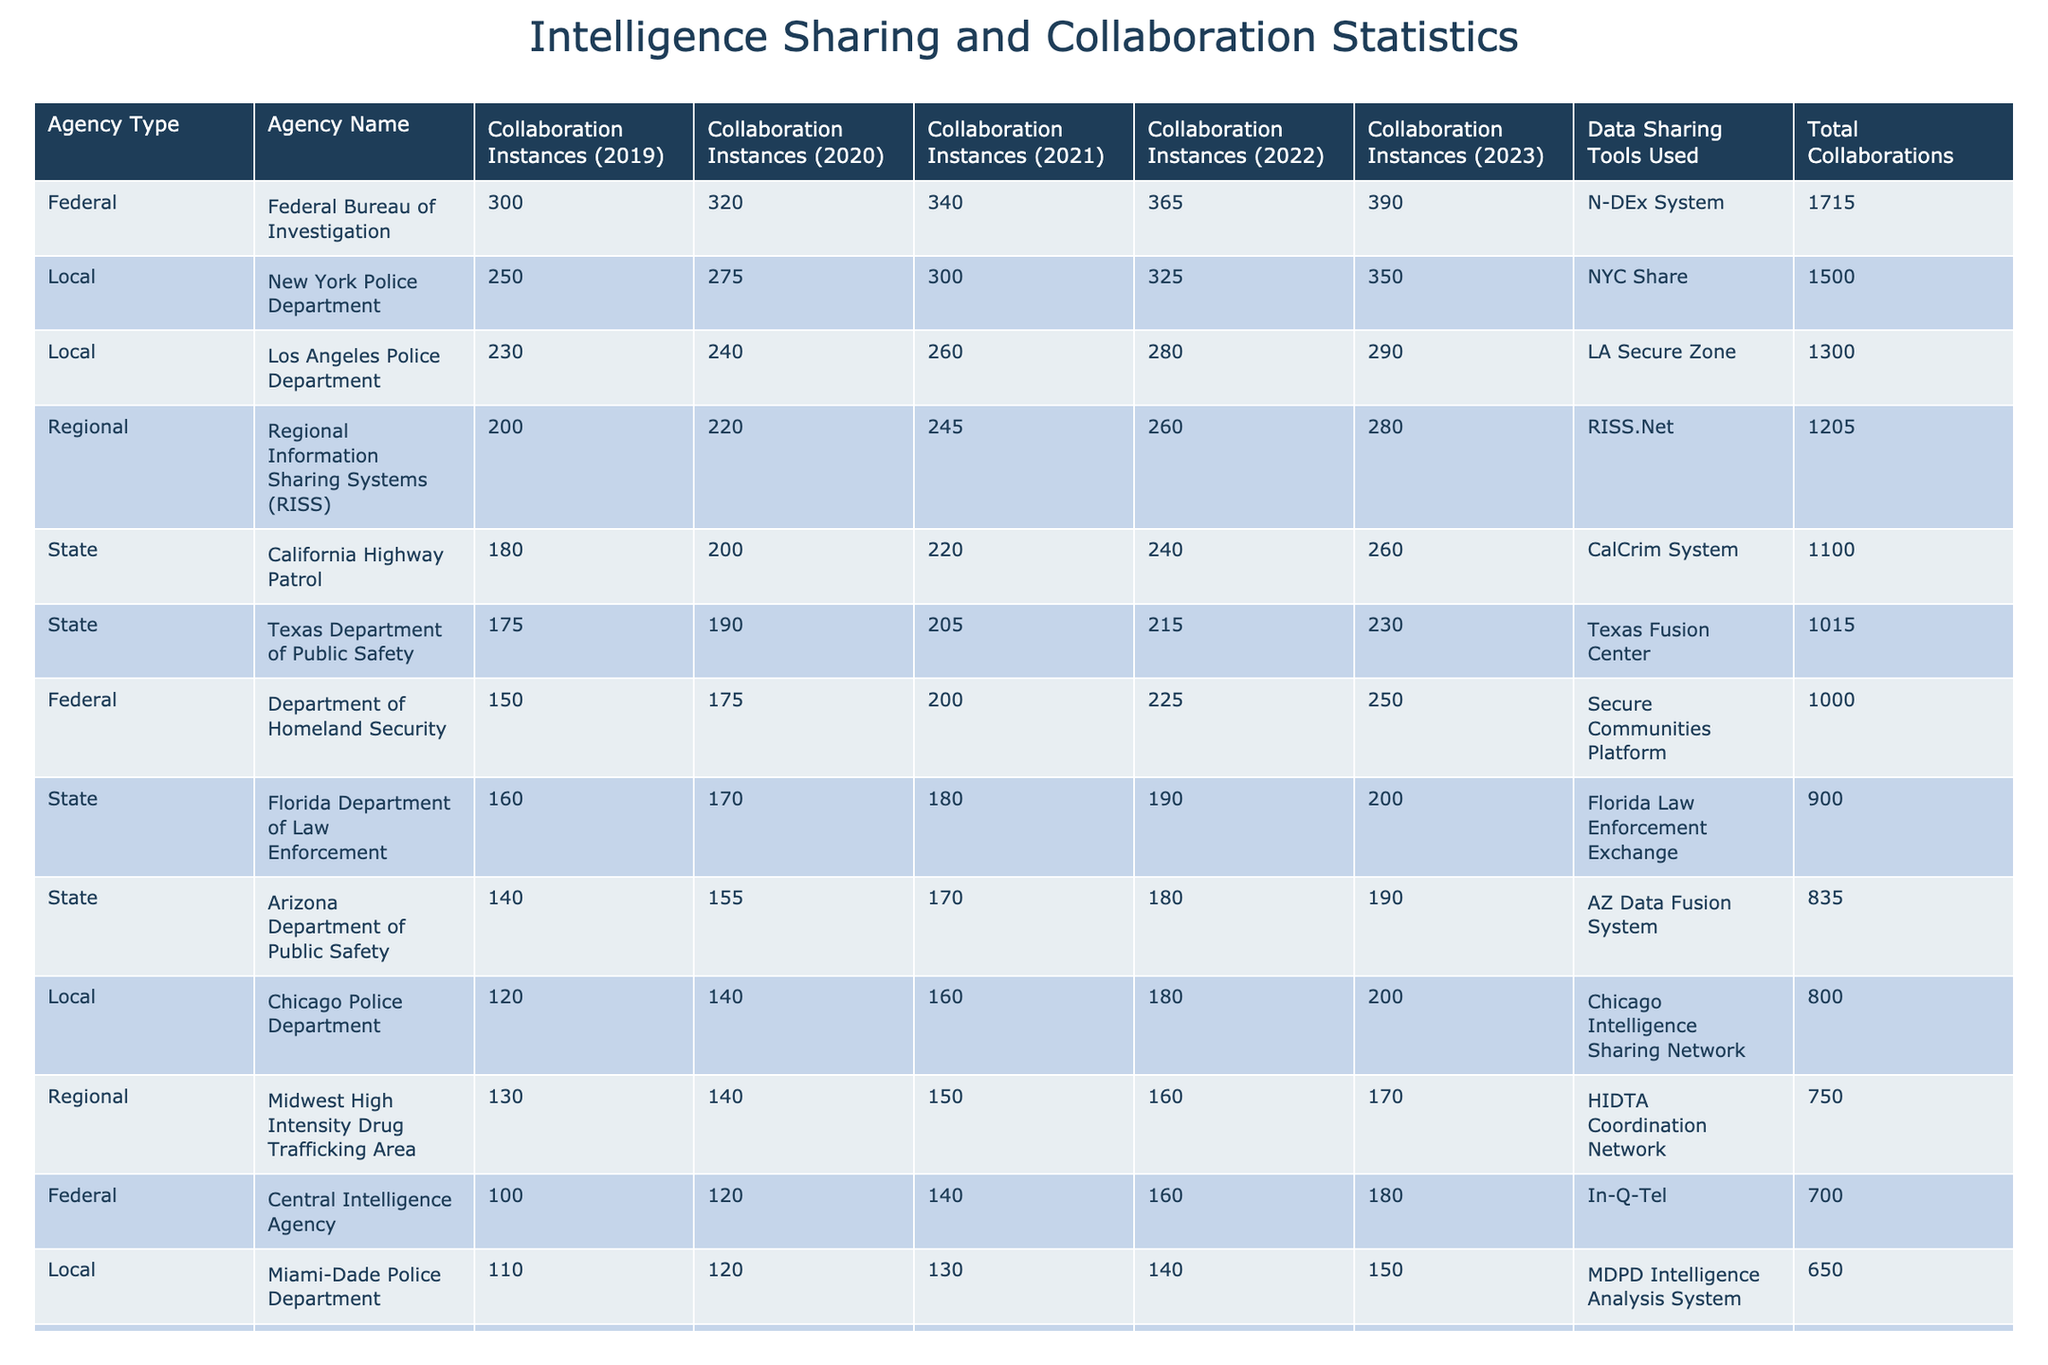What is the total number of collaboration instances for the Federal Bureau of Investigation from 2019 to 2023? Adding the collaboration instances from the table for the Federal Bureau of Investigation: 300 + 320 + 340 + 365 + 390 = 1715.
Answer: 1715 Which agency had the highest total collaboration instances in the year 2023? From the table, I locate the year 2023 and check the collaboration instances: FBI (390), NYPD (350), DHS (250). The FBI has the highest instances of 390.
Answer: FBI How many collaboration instances did the California Highway Patrol have in 2021? Looking at the California Highway Patrol row in the 2021 column, it shows 220 collaboration instances.
Answer: 220 What is the average number of collaboration instances for the New York Police Department over the five years? Adding the collaboration instances for NYPD: 250 + 275 + 300 + 325 + 350 = 1500. Then dividing by 5 gives 1500/5 = 300.
Answer: 300 Did the Drug Enforcement Administration have more collaboration instances in 2022 than in 2021? Checking the DEA row for 2021 (110) and 2022 (120), I find that 120 is greater than 110, indicating yes.
Answer: Yes Which agency saw the largest increase in collaboration instances from 2019 to 2023? I compare the 2019 and 2023 instances for each agency. DHS increased from 150 to 250 (+100), FBI from 300 to 390 (+90), and others less so. DHS had the largest increase.
Answer: DHS In 2020, what was the total number of collaboration instances for all local law enforcement agencies combined? Adding local agencies: NYPD (275) + LAPD (240) + Chicago (140) + Houston (115) + Boston (110) + Miami-Dade (120) + Philadelphia (100) = 1100.
Answer: 1100 What percentage of the total collaboration instances in 2023 were by state agencies? For 2023, total state collaborations: CHP (260) + FL (200) + TX (230) + AZ (190) = 880. The total for 2023 is 390 + 350 + 250 + 130 + 100 + 100 + 880 = 2200. The percentage is (880/2200) * 100 = 40%.
Answer: 40% What is the trend in collaboration instances for the Central Intelligence Agency from 2019 to 2023? Observing the instances: 100, 120, 140, 160, 180. This shows a consistent increase each year.
Answer: Increasing Which agency had the lowest number of collaboration instances in 2022? Checking the 2022 column, I see the agency with the lowest instances is the United States Secret Service with 95.
Answer: US Secret Service 